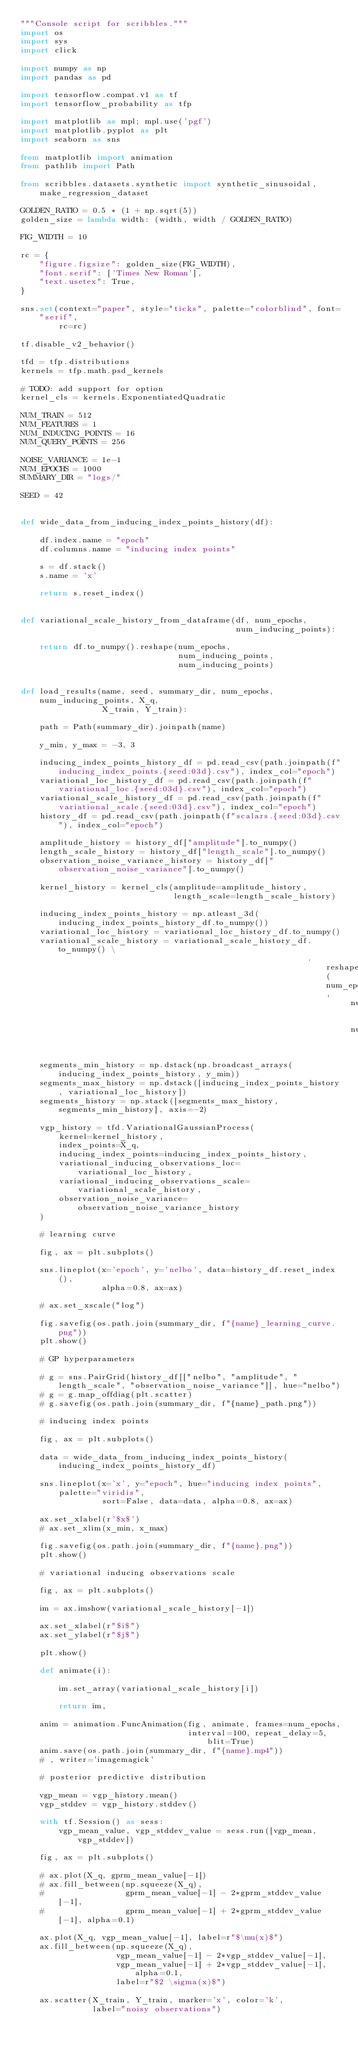<code> <loc_0><loc_0><loc_500><loc_500><_Python_>"""Console script for scribbles."""
import os
import sys
import click

import numpy as np
import pandas as pd

import tensorflow.compat.v1 as tf
import tensorflow_probability as tfp

import matplotlib as mpl; mpl.use('pgf')
import matplotlib.pyplot as plt
import seaborn as sns

from matplotlib import animation
from pathlib import Path

from scribbles.datasets.synthetic import synthetic_sinusoidal, make_regression_dataset

GOLDEN_RATIO = 0.5 * (1 + np.sqrt(5))
golden_size = lambda width: (width, width / GOLDEN_RATIO)

FIG_WIDTH = 10

rc = {
    "figure.figsize": golden_size(FIG_WIDTH),
    "font.serif": ['Times New Roman'],
    "text.usetex": True,
}

sns.set(context="paper", style="ticks", palette="colorblind", font="serif",
        rc=rc)

tf.disable_v2_behavior()

tfd = tfp.distributions
kernels = tfp.math.psd_kernels

# TODO: add support for option
kernel_cls = kernels.ExponentiatedQuadratic

NUM_TRAIN = 512
NUM_FEATURES = 1
NUM_INDUCING_POINTS = 16
NUM_QUERY_POINTS = 256

NOISE_VARIANCE = 1e-1
NUM_EPOCHS = 1000
SUMMARY_DIR = "logs/"

SEED = 42


def wide_data_from_inducing_index_points_history(df):

    df.index.name = "epoch"
    df.columns.name = "inducing index points"

    s = df.stack()
    s.name = 'x'

    return s.reset_index()


def variational_scale_history_from_dataframe(df, num_epochs,
                                             num_inducing_points):

    return df.to_numpy().reshape(num_epochs,
                                 num_inducing_points,
                                 num_inducing_points)


def load_results(name, seed, summary_dir, num_epochs, num_inducing_points, X_q,
                 X_train, Y_train):

    path = Path(summary_dir).joinpath(name)

    y_min, y_max = -3, 3

    inducing_index_points_history_df = pd.read_csv(path.joinpath(f"inducing_index_points.{seed:03d}.csv"), index_col="epoch")
    variational_loc_history_df = pd.read_csv(path.joinpath(f"variational_loc.{seed:03d}.csv"), index_col="epoch")
    variational_scale_history_df = pd.read_csv(path.joinpath(f"variational_scale.{seed:03d}.csv"), index_col="epoch")
    history_df = pd.read_csv(path.joinpath(f"scalars.{seed:03d}.csv"), index_col="epoch")

    amplitude_history = history_df["amplitude"].to_numpy()
    length_scale_history = history_df["length_scale"].to_numpy()
    observation_noise_variance_history = history_df["observation_noise_variance"].to_numpy()

    kernel_history = kernel_cls(amplitude=amplitude_history,
                                length_scale=length_scale_history)

    inducing_index_points_history = np.atleast_3d(inducing_index_points_history_df.to_numpy())
    variational_loc_history = variational_loc_history_df.to_numpy()
    variational_scale_history = variational_scale_history_df.to_numpy() \
                                                            .reshape(num_epochs,
                                                                     num_inducing_points,
                                                                     num_inducing_points)

    segments_min_history = np.dstack(np.broadcast_arrays(inducing_index_points_history, y_min))
    segments_max_history = np.dstack([inducing_index_points_history, variational_loc_history])
    segments_history = np.stack([segments_max_history, segments_min_history], axis=-2)

    vgp_history = tfd.VariationalGaussianProcess(
        kernel=kernel_history,
        index_points=X_q,
        inducing_index_points=inducing_index_points_history,
        variational_inducing_observations_loc=variational_loc_history,
        variational_inducing_observations_scale=variational_scale_history,
        observation_noise_variance=observation_noise_variance_history
    )

    # learning curve

    fig, ax = plt.subplots()

    sns.lineplot(x='epoch', y='nelbo', data=history_df.reset_index(),
                 alpha=0.8, ax=ax)

    # ax.set_xscale("log")

    fig.savefig(os.path.join(summary_dir, f"{name}_learning_curve.png"))
    plt.show()

    # GP hyperparameters

    # g = sns.PairGrid(history_df[["nelbo", "amplitude", "length_scale", "observation_noise_variance"]], hue="nelbo")
    # g = g.map_offdiag(plt.scatter)
    # g.savefig(os.path.join(summary_dir, f"{name}_path.png"))

    # inducing index points

    fig, ax = plt.subplots()

    data = wide_data_from_inducing_index_points_history(inducing_index_points_history_df)

    sns.lineplot(x='x', y="epoch", hue="inducing index points", palette="viridis",
                 sort=False, data=data, alpha=0.8, ax=ax)

    ax.set_xlabel(r'$x$')
    # ax.set_xlim(x_min, x_max)

    fig.savefig(os.path.join(summary_dir, f"{name}.png"))
    plt.show()

    # variational inducing observations scale

    fig, ax = plt.subplots()

    im = ax.imshow(variational_scale_history[-1])

    ax.set_xlabel(r"$i$")
    ax.set_ylabel(r"$j$")

    plt.show()

    def animate(i):

        im.set_array(variational_scale_history[i])

        return im,

    anim = animation.FuncAnimation(fig, animate, frames=num_epochs,
                                   interval=100, repeat_delay=5, blit=True)
    anim.save(os.path.join(summary_dir, f"{name}.mp4"))
    # , writer='imagemagick'

    # posterior predictive distribution

    vgp_mean = vgp_history.mean()
    vgp_stddev = vgp_history.stddev()

    with tf.Session() as sess:
        vgp_mean_value, vgp_stddev_value = sess.run([vgp_mean, vgp_stddev])

    fig, ax = plt.subplots()

    # ax.plot(X_q, gprm_mean_value[-1])
    # ax.fill_between(np.squeeze(X_q),
    #                 gprm_mean_value[-1] - 2*gprm_stddev_value[-1],
    #                 gprm_mean_value[-1] + 2*gprm_stddev_value[-1], alpha=0.1)

    ax.plot(X_q, vgp_mean_value[-1], label=r"$\mu(x)$")
    ax.fill_between(np.squeeze(X_q),
                    vgp_mean_value[-1] - 2*vgp_stddev_value[-1],
                    vgp_mean_value[-1] + 2*vgp_stddev_value[-1], alpha=0.1,
                    label=r"$2 \sigma(x)$")

    ax.scatter(X_train, Y_train, marker='x', color='k',
               label="noisy observations")
</code> 